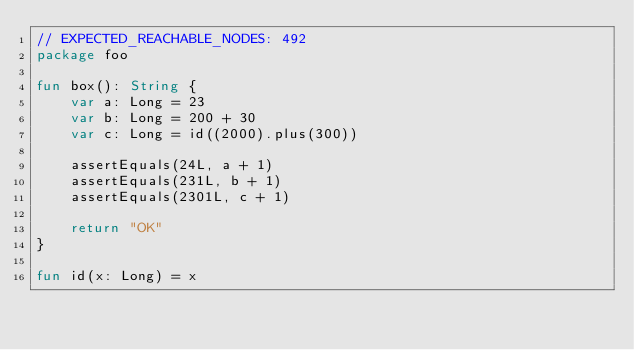Convert code to text. <code><loc_0><loc_0><loc_500><loc_500><_Kotlin_>// EXPECTED_REACHABLE_NODES: 492
package foo

fun box(): String {
    var a: Long = 23
    var b: Long = 200 + 30
    var c: Long = id((2000).plus(300))

    assertEquals(24L, a + 1)
    assertEquals(231L, b + 1)
    assertEquals(2301L, c + 1)

    return "OK"
}

fun id(x: Long) = x</code> 